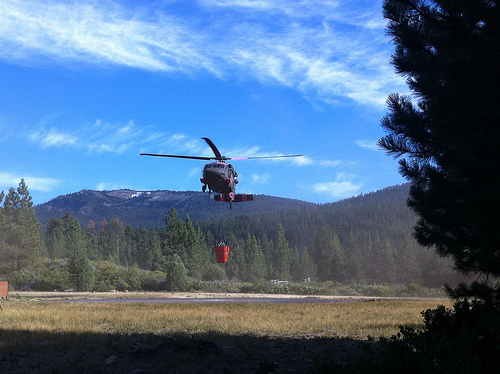<image>
Is the helicopter above the bag? Yes. The helicopter is positioned above the bag in the vertical space, higher up in the scene. 